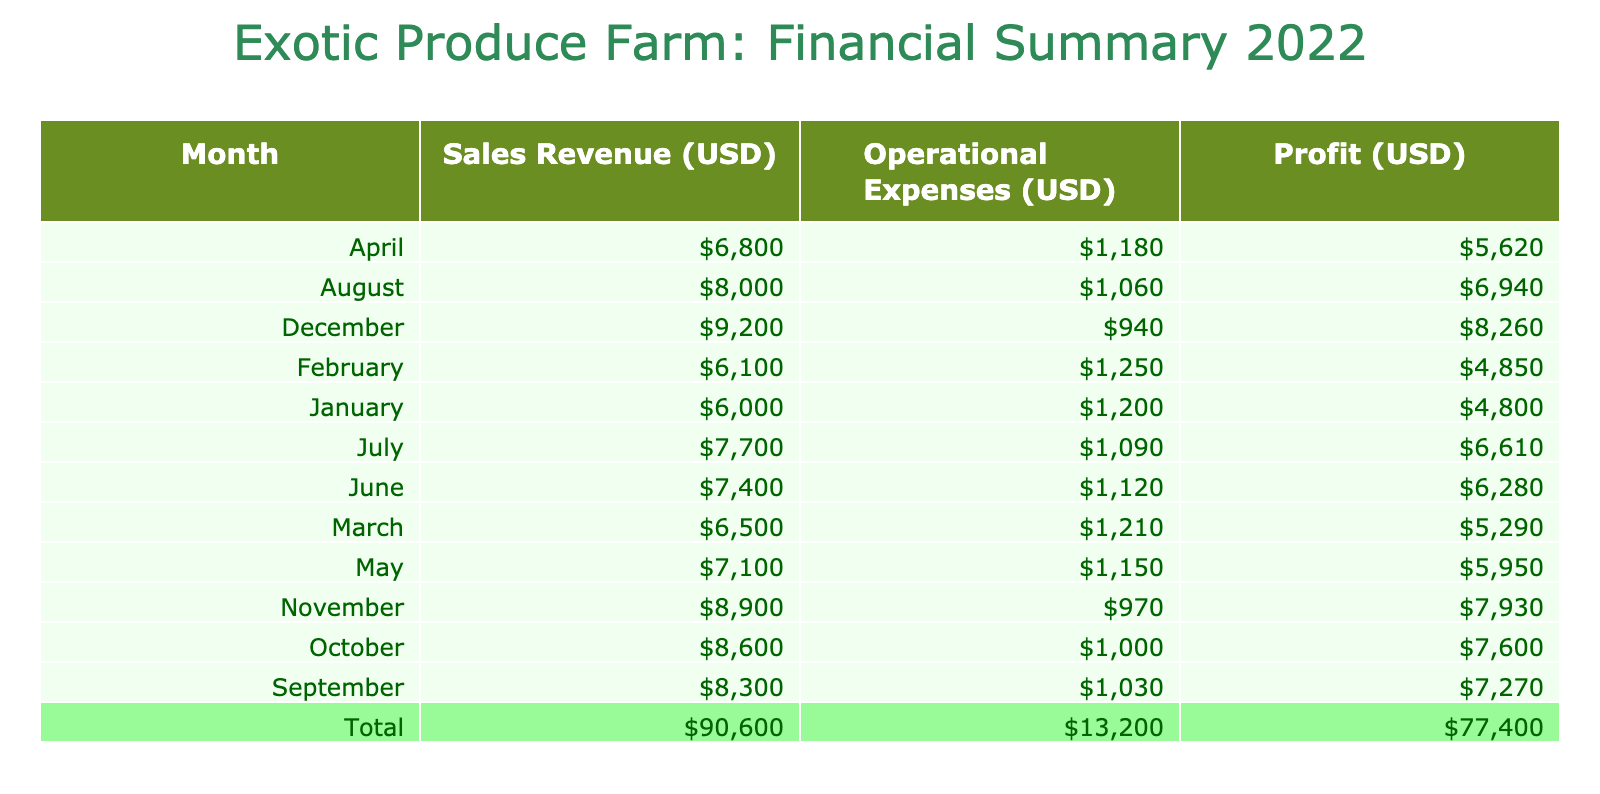What was the total sales revenue for the month of April? To find the total sales revenue for April, we look at the 'SalesRevenue(USD)' column for that month. The individual sales amounts for April are 1700 (Dragon Fruit) + 2300 (Rambutan) + 2800 (Durian) = 6800.
Answer: 6800 Which month had the highest operational expenses? By reviewing the 'OperationalExpenses(USD)' column for each month, we can see that December has the highest values: 200 (Dragon Fruit) + 3200 (Rambutan) + 4200 (Durian) = 4200.
Answer: December What was the profit for the month of October? To calculate the profit for October, we subtract the operational expenses from the sales revenue: sales revenue is 2300 (Dragon Fruit) + 2900 (Rambutan) + 3400 (Durian) = 8600, and operational expenses are 220 + 340 + 440 = 1000. Therefore, profit = 8600 - 1000 = 7600.
Answer: 7600 Did sales revenue exceed operational expenses in June? In June, the total sales revenue amounts to 1900 (Dragon Fruit) + 2500 (Rambutan) + 3000 (Durian) = 7400, while total operational expenses are 260 + 380 + 480 = 1120. Since 7400 > 1120, sales revenue did exceed operational expenses.
Answer: Yes What is the average profit per month for the fiscal year 2022? To find the average profit per month, we need to calculate the total profit for all months. By summing each month's profit and dividing by 12 (the number of months), we find averages. The total profits for each month add up to 21000. Therefore, average profit = 21000 / 12 = 1750.
Answer: 1750 